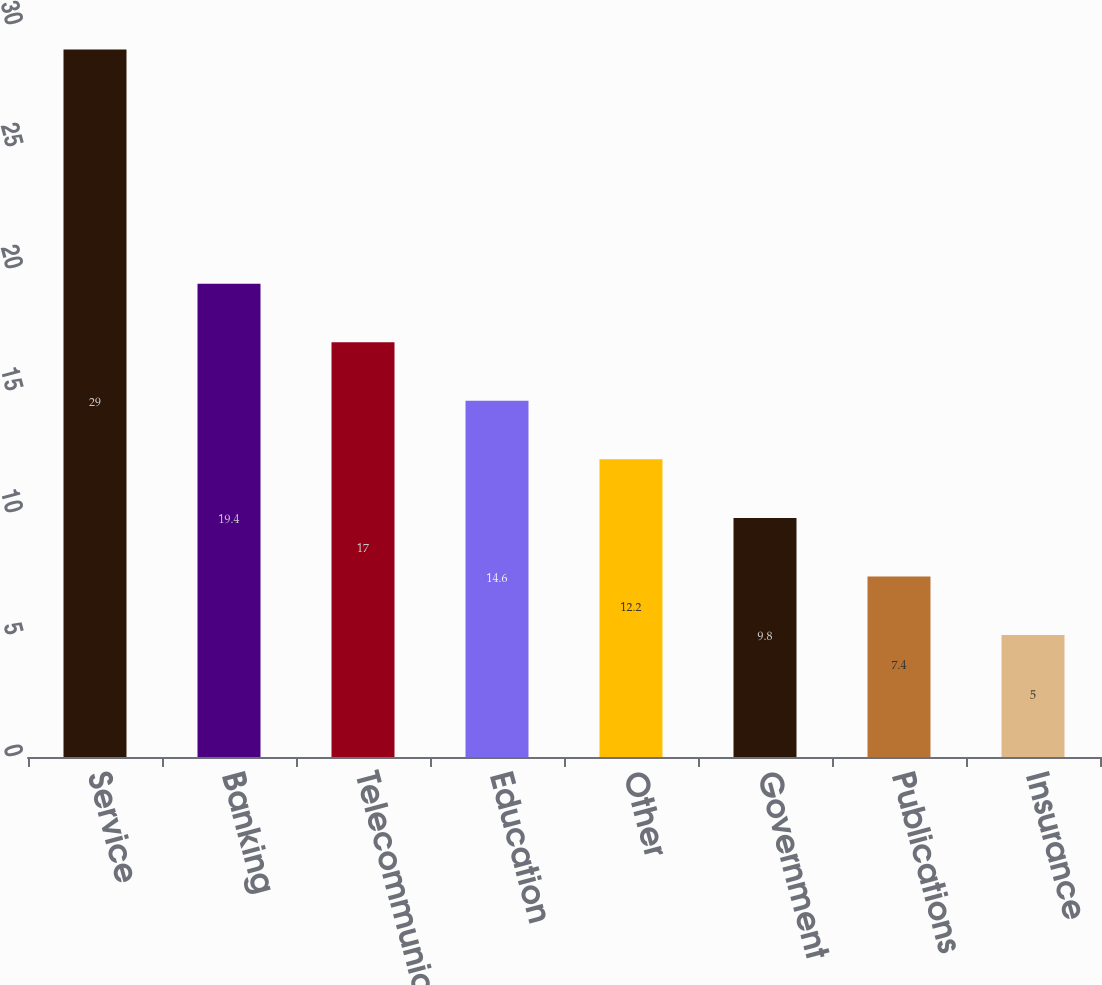Convert chart. <chart><loc_0><loc_0><loc_500><loc_500><bar_chart><fcel>Service<fcel>Banking<fcel>Telecommunications<fcel>Education<fcel>Other<fcel>Government<fcel>Publications<fcel>Insurance<nl><fcel>29<fcel>19.4<fcel>17<fcel>14.6<fcel>12.2<fcel>9.8<fcel>7.4<fcel>5<nl></chart> 